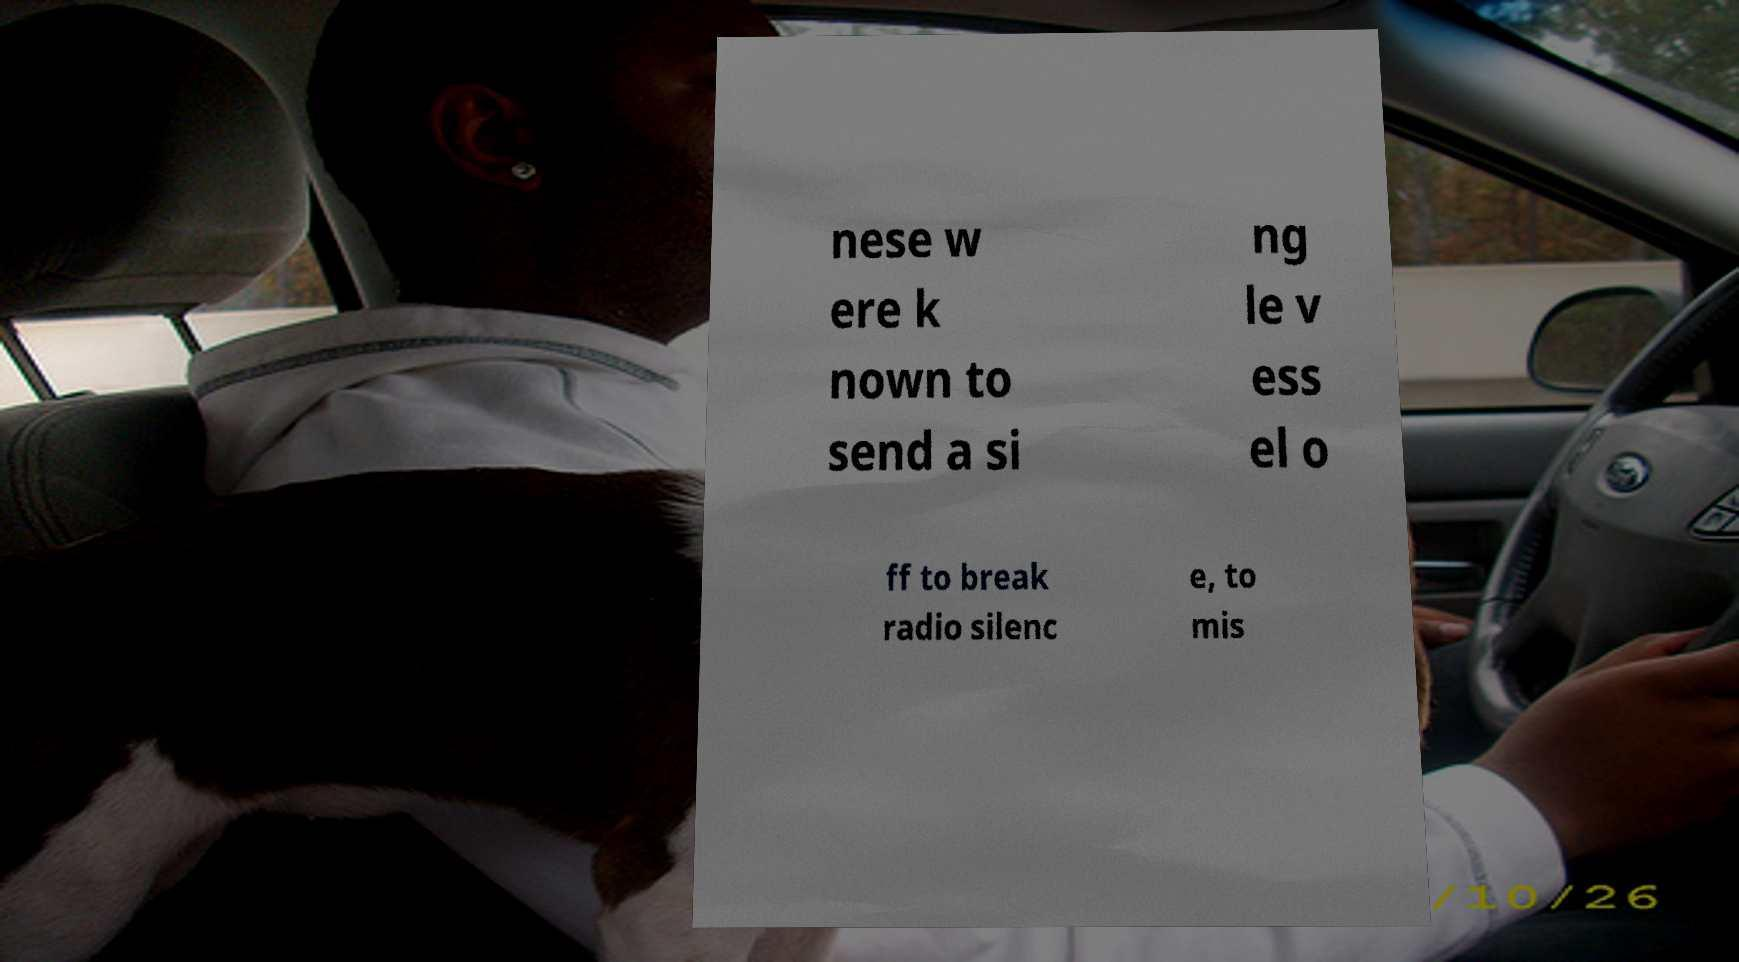Please identify and transcribe the text found in this image. nese w ere k nown to send a si ng le v ess el o ff to break radio silenc e, to mis 